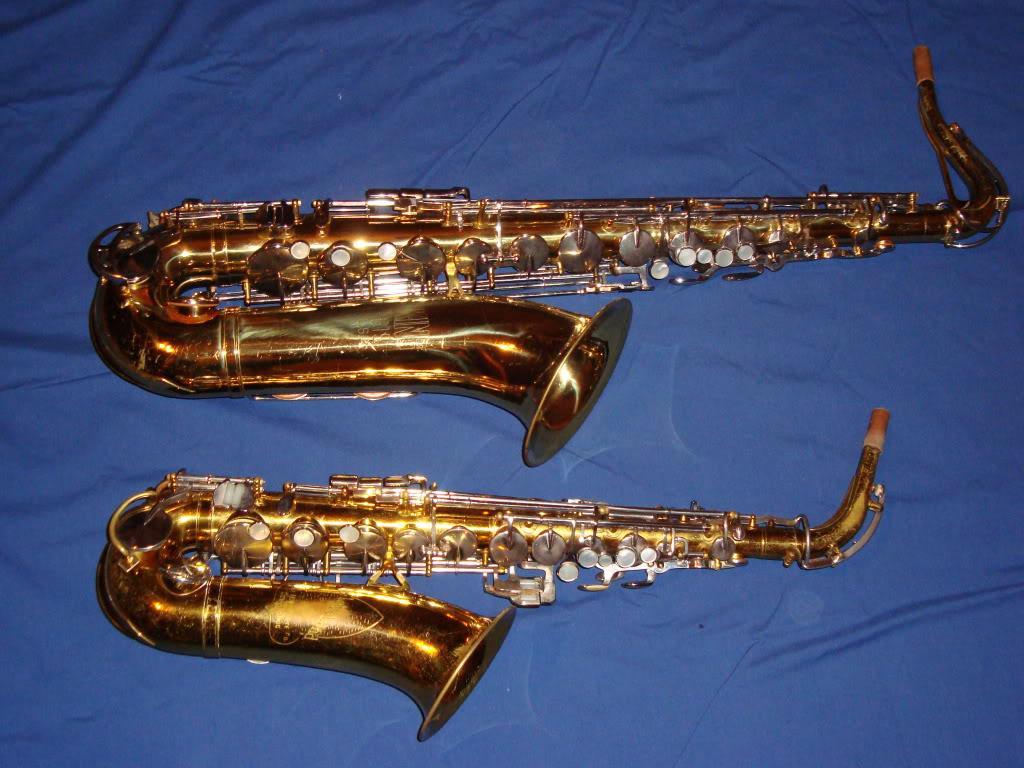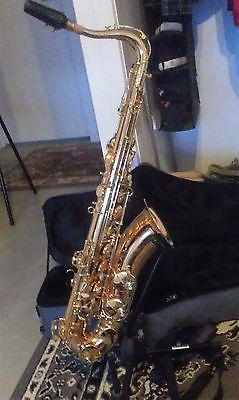The first image is the image on the left, the second image is the image on the right. For the images shown, is this caption "There are no more than 3 saxophones." true? Answer yes or no. Yes. The first image is the image on the left, the second image is the image on the right. For the images shown, is this caption "There are more than four saxophones in total." true? Answer yes or no. No. 